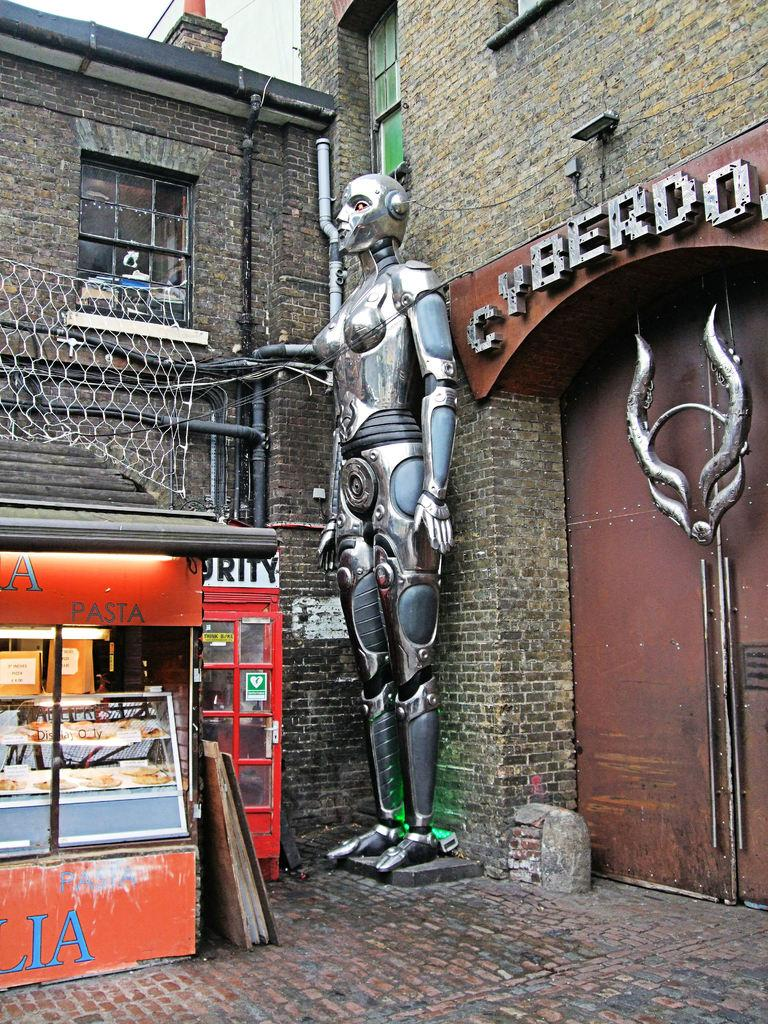What type of road is visible in the image? There is a brick road in the image. What kind of establishment can be seen in the image? There is a food store in the image. What other structure is present in the image? There is a telephone booth in the image. Can you describe the statue in the image? There is a robot statue in the image. What architectural feature is present in the image? There is a gate in the image. What sign is visible in the image? There is a name board in the image. What type of buildings are in the image? There are brick buildings in the image. What infrastructure elements can be seen in the image? There are pipes and wires in the image. What can be seen in the background of the image? The sky is visible in the background of the image. How many tomatoes are hanging from the wires in the image? There are no tomatoes present in the image; only pipes and wires can be seen. What type of bottle is placed on the robot statue in the image? There is no bottle present on the robot statue in the image. 